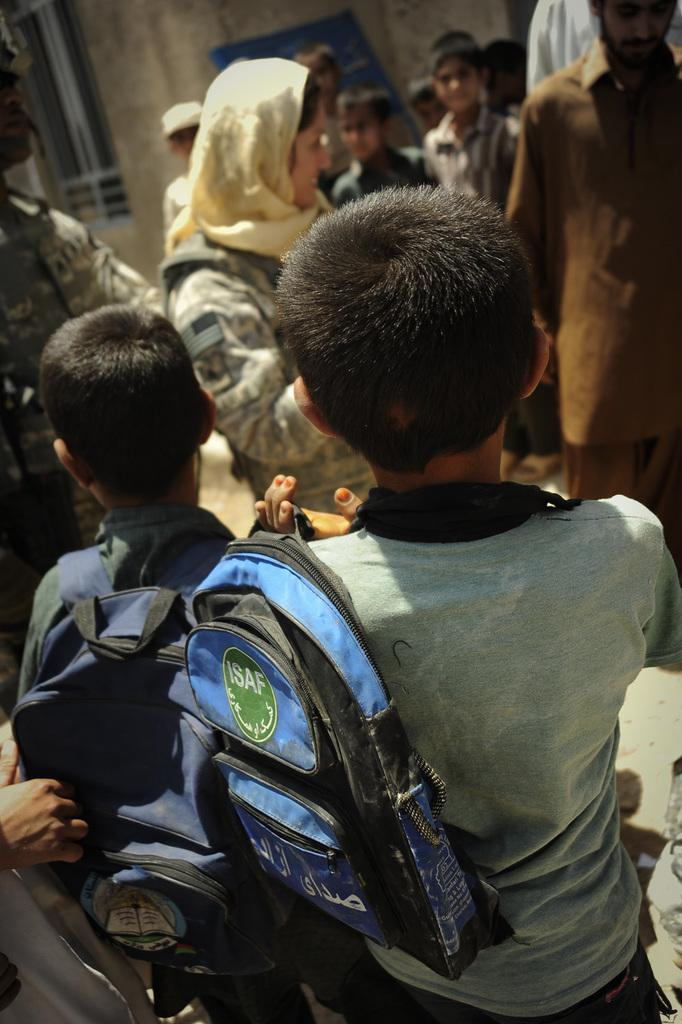What can be seen in the image? There are children in the image. What are the children wearing? The children are wearing bags. Where are the children standing? The children are standing on the road. Are there any other people in the image? Yes, there are other persons in the image. How many children are present in the image? There are other children in the image. What is visible in the background of the image? There is a building in the background of the image. Can you describe the building? The building has a window. What is the thought process of the middle child in the image? There is no information about the thought process of any child in the image, as we cannot see inside their minds. 